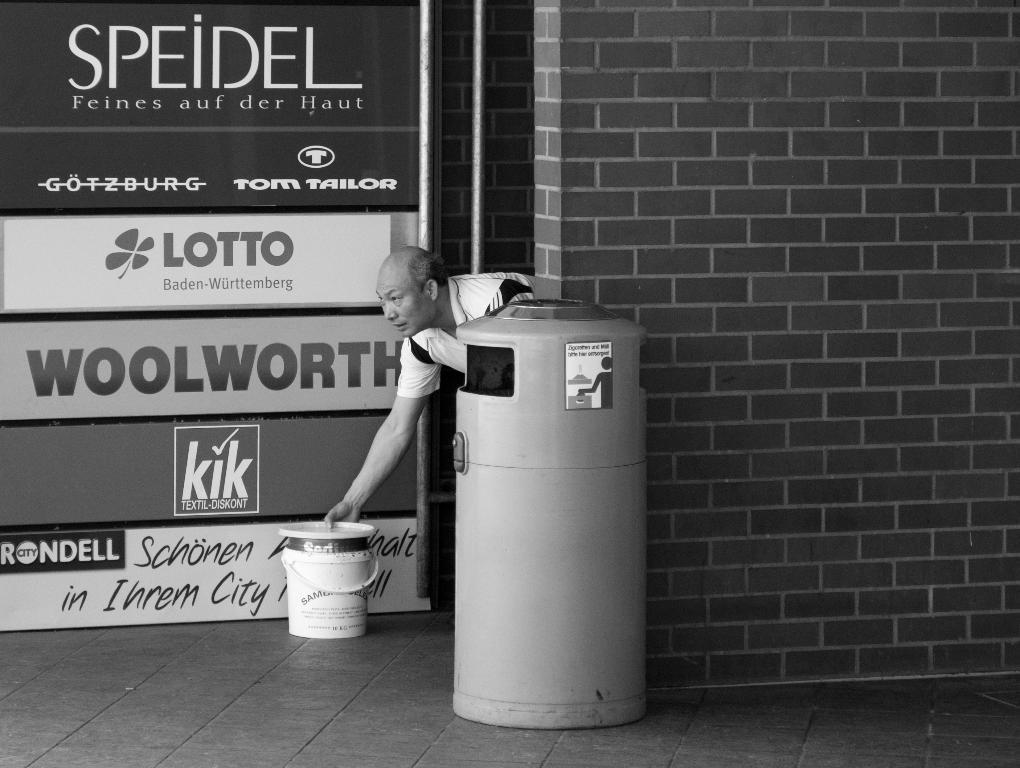Provide a one-sentence caption for the provided image. Advertisements for Woolworth and kik and Lotto and Speidel. 